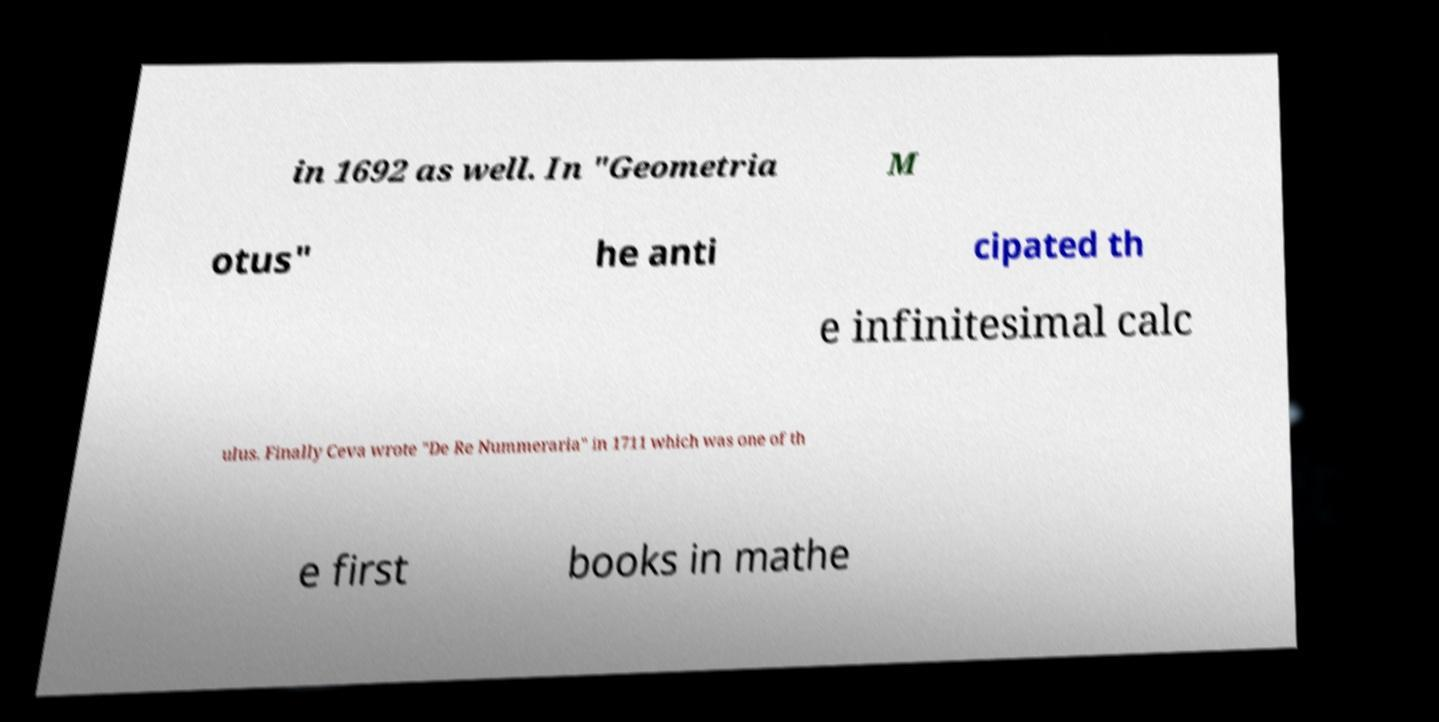Please read and relay the text visible in this image. What does it say? in 1692 as well. In "Geometria M otus" he anti cipated th e infinitesimal calc ulus. Finally Ceva wrote "De Re Nummeraria" in 1711 which was one of th e first books in mathe 